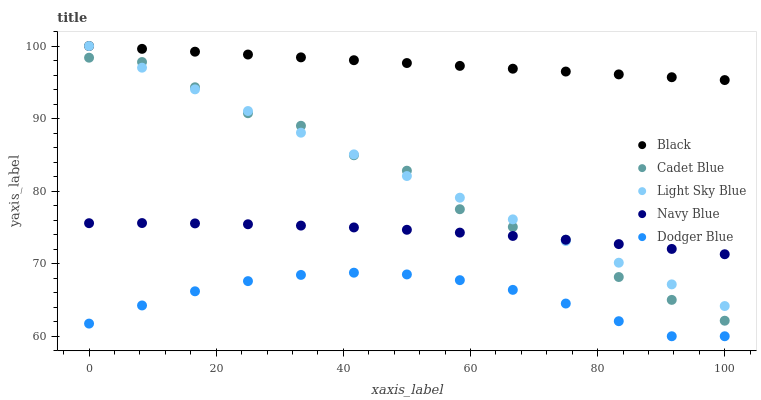Does Dodger Blue have the minimum area under the curve?
Answer yes or no. Yes. Does Black have the maximum area under the curve?
Answer yes or no. Yes. Does Cadet Blue have the minimum area under the curve?
Answer yes or no. No. Does Cadet Blue have the maximum area under the curve?
Answer yes or no. No. Is Light Sky Blue the smoothest?
Answer yes or no. Yes. Is Cadet Blue the roughest?
Answer yes or no. Yes. Is Black the smoothest?
Answer yes or no. No. Is Black the roughest?
Answer yes or no. No. Does Dodger Blue have the lowest value?
Answer yes or no. Yes. Does Cadet Blue have the lowest value?
Answer yes or no. No. Does Light Sky Blue have the highest value?
Answer yes or no. Yes. Does Cadet Blue have the highest value?
Answer yes or no. No. Is Navy Blue less than Black?
Answer yes or no. Yes. Is Navy Blue greater than Dodger Blue?
Answer yes or no. Yes. Does Cadet Blue intersect Navy Blue?
Answer yes or no. Yes. Is Cadet Blue less than Navy Blue?
Answer yes or no. No. Is Cadet Blue greater than Navy Blue?
Answer yes or no. No. Does Navy Blue intersect Black?
Answer yes or no. No. 